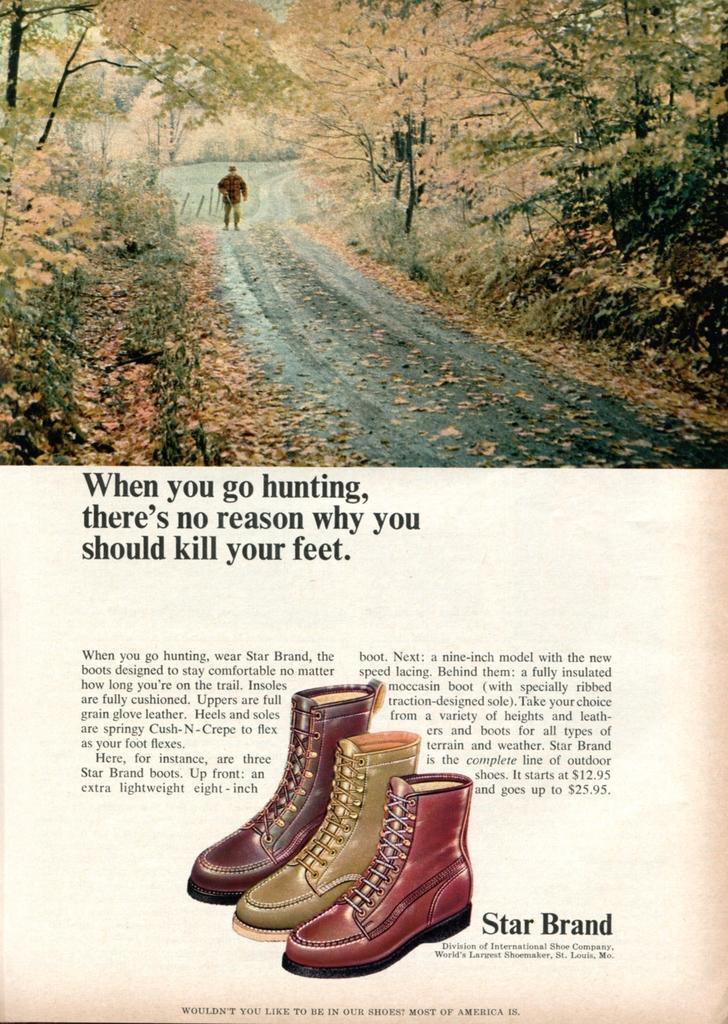In one or two sentences, can you explain what this image depicts? In this image I can see a paper. To the top of the image I can see a picture in which I can see the road, few leaves on the road, a person standing and few trees. I can see something is written on the paper and three different shoes to the bottom of the image. 